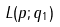Convert formula to latex. <formula><loc_0><loc_0><loc_500><loc_500>L ( p ; q _ { 1 } )</formula> 